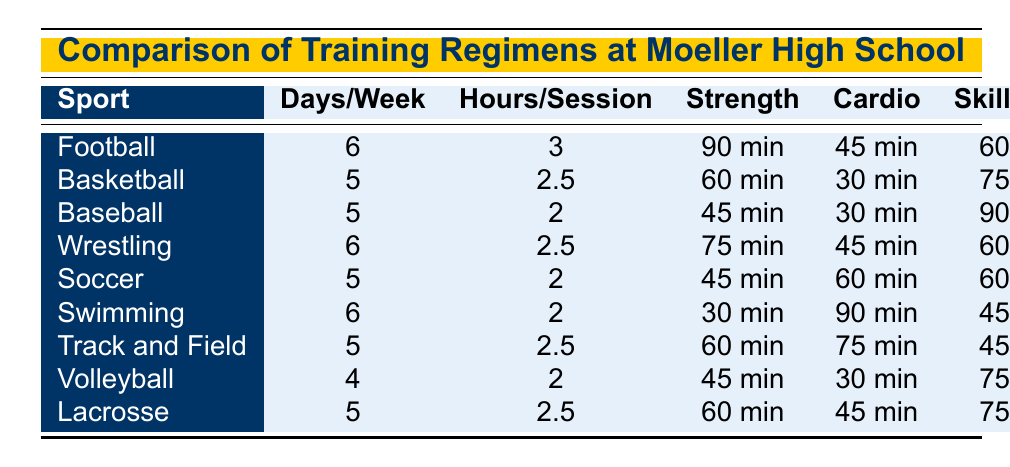What sport has the highest number of training days per week? By looking at the training regimens for each sport, we find that Football and Wrestling both have 6 days of training per week, which is the highest compared to any other sport listed.
Answer: Football and Wrestling How many hours per session do Soccer athletes train? The training regimen for Soccer indicates that athletes train for 2 hours per session.
Answer: 2 hours Which sport has the longest strength training session? Referring to the table, Football has the longest strength training session at 90 minutes.
Answer: Football Is Volleyball trained more days per week than Swimming? Volleyball is trained for 4 days per week, while Swimming is trained for 6 days per week, making it false that Volleyball is trained more days.
Answer: No What is the total duration of skill drills for all sports combined? To find the total duration of skill drills, we sum up the duration for each sport: 60 + 75 + 90 + 60 + 60 + 45 + 45 + 75 + 75 = 675 minutes for skill drills across all listed sports.
Answer: 675 minutes Which sport has the shortest recovery time? Looking at the recovery times, Basketball, Baseball, Soccer, and Swimming all have the shortest recovery time of 15 minutes.
Answer: Basketball, Baseball, Soccer, and Swimming What is the average duration of cardiovascular training across all sports? Calculating the average duration involves: (45 + 30 + 30 + 45 + 60 + 90 + 75 + 30 + 45) = 450 minutes total across 9 sports, resulting in an average of 450 / 9 = 50 minutes.
Answer: 50 minutes Which sports require more than 60 minutes of strength training? Observing the strength training durations, only Football (90 min) and Wrestling (75 min) require more than 60 minutes for strength training.
Answer: Football and Wrestling How does Baseball's skill drill duration compare to Basketball's? Baseball has a skill drill duration of 90 minutes, while Basketball’s is 75 minutes, indicating that Baseball has 15 minutes longer skill drills than Basketball.
Answer: 15 minutes longer Which sport has the same hours per session as Track and Field? Track and Field athletes train for 2.5 hours per session, the same duration as both Wrestling and Lacrosse.
Answer: Wrestling and Lacrosse 